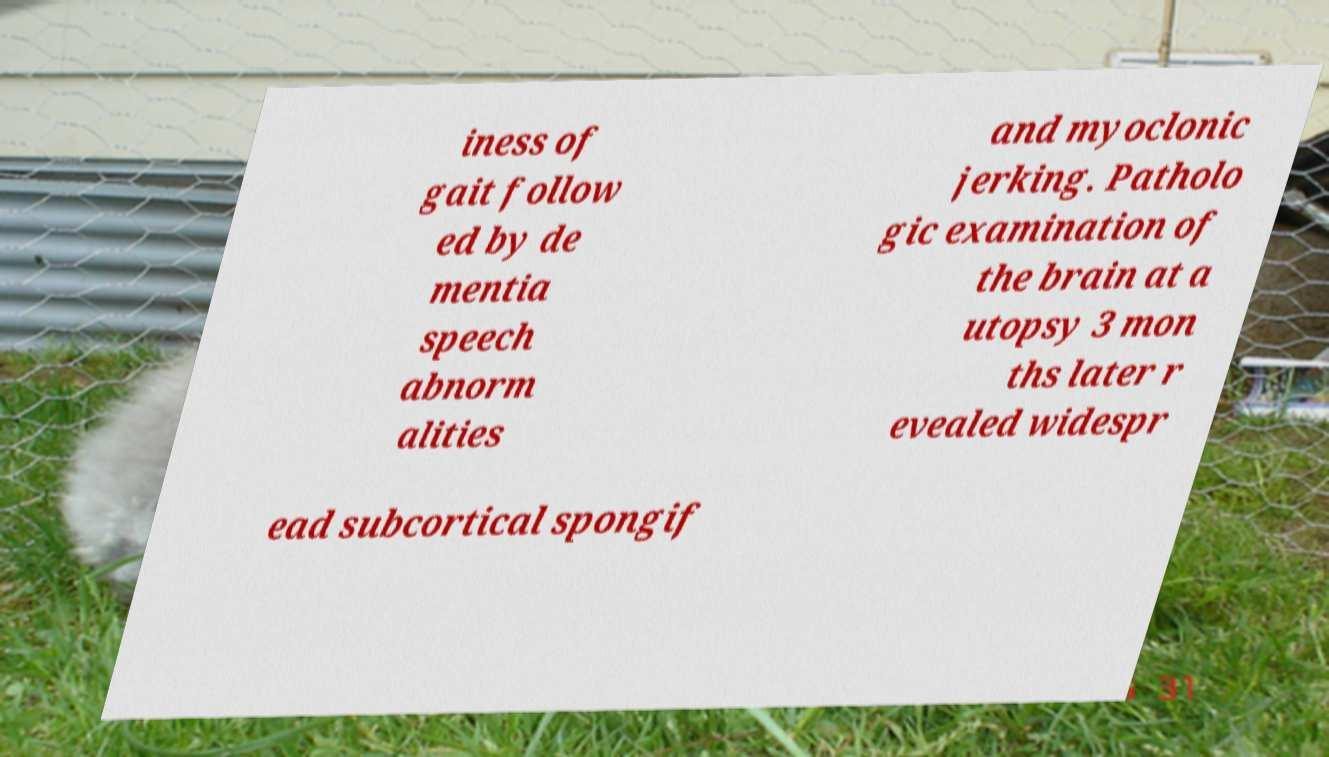Can you accurately transcribe the text from the provided image for me? iness of gait follow ed by de mentia speech abnorm alities and myoclonic jerking. Patholo gic examination of the brain at a utopsy 3 mon ths later r evealed widespr ead subcortical spongif 